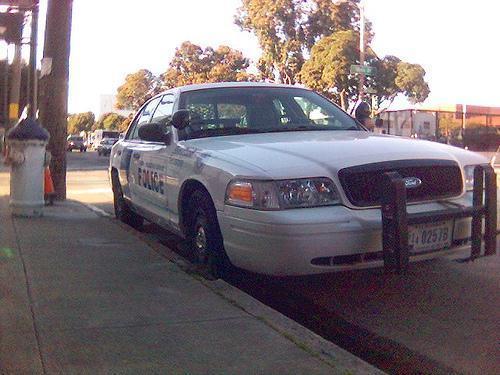How many people are in the shot?
Give a very brief answer. 0. 